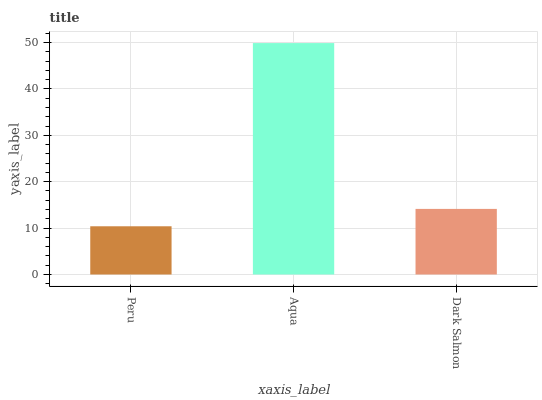Is Dark Salmon the minimum?
Answer yes or no. No. Is Dark Salmon the maximum?
Answer yes or no. No. Is Aqua greater than Dark Salmon?
Answer yes or no. Yes. Is Dark Salmon less than Aqua?
Answer yes or no. Yes. Is Dark Salmon greater than Aqua?
Answer yes or no. No. Is Aqua less than Dark Salmon?
Answer yes or no. No. Is Dark Salmon the high median?
Answer yes or no. Yes. Is Dark Salmon the low median?
Answer yes or no. Yes. Is Aqua the high median?
Answer yes or no. No. Is Aqua the low median?
Answer yes or no. No. 